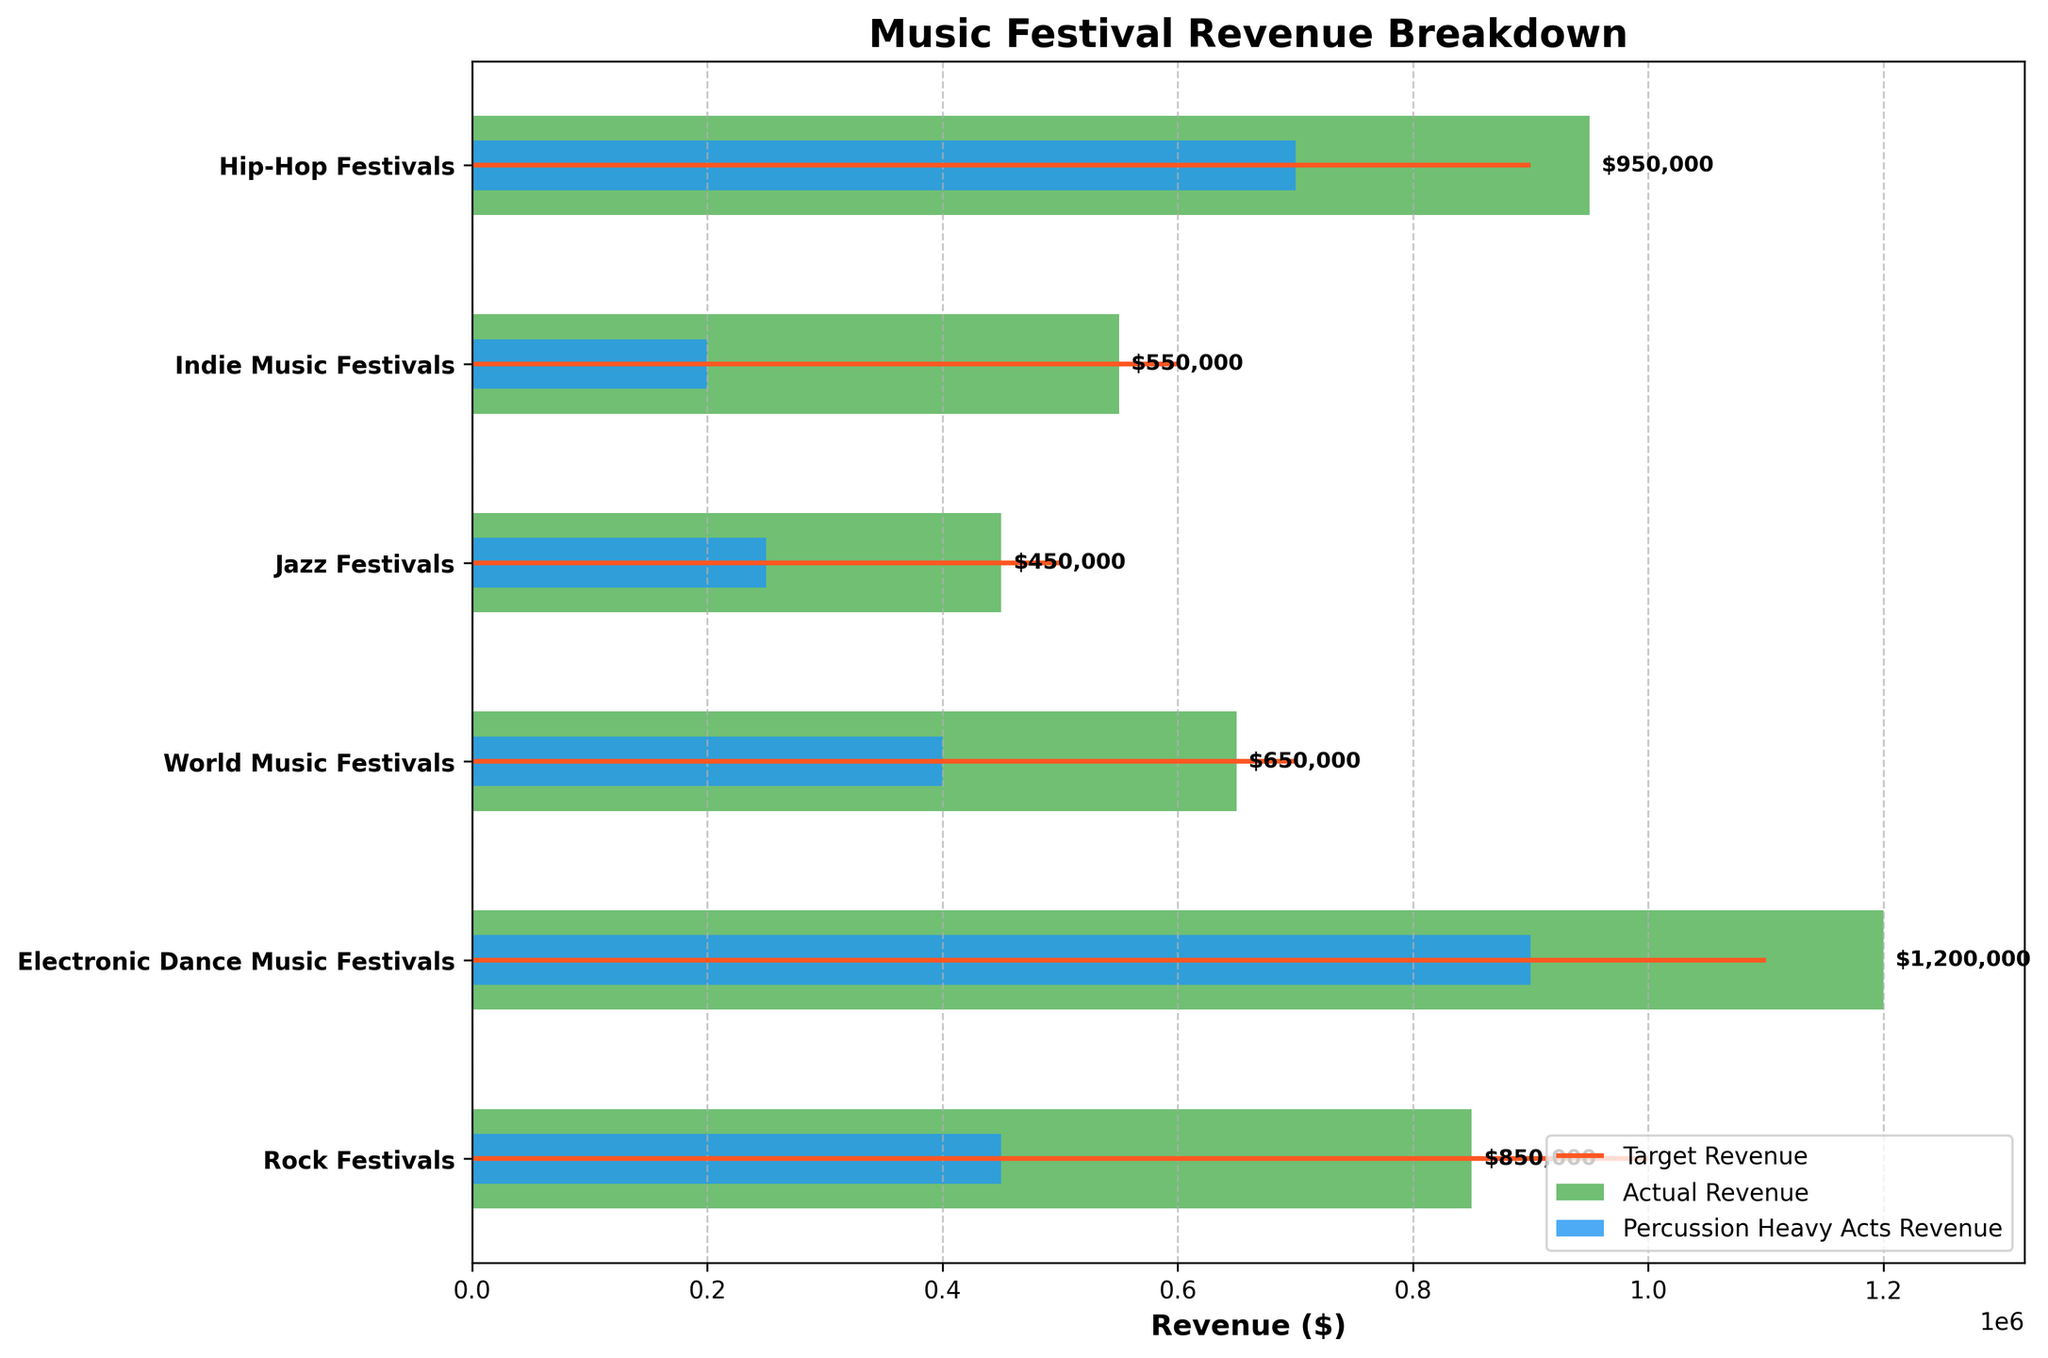What's the title of the chart? The title of the chart is usually found at the top and provides an overview of what the chart represents. In this chart, the title clearly indicates the content.
Answer: Music Festival Revenue Breakdown Which festival has the highest actual revenue? To determine the highest actual revenue, look for the longest green bar in the chart.
Answer: Electronic Dance Music Festivals What is the revenue from percussion-heavy acts for Indie Music Festivals? The blue bar represents the revenue from percussion-heavy acts, and for Indie Music Festivals, this bar is the shortest blue bar in the chart.
Answer: $200,000 How does the actual revenue for Jazz Festivals compare to its target revenue? By observing the length of the green bar (actual revenue) and the red line (target revenue) for Jazz Festivals, you can see if the actual revenue is less than or more than the target.
Answer: Less than the target What is the total actual revenue generated by all festivals? Sum the actual revenue values for all the festivals: 850,000 (Rock) + 1,200,000 (EDM) + 650,000 (World) + 450,000 (Jazz) + 550,000 (Indie) + 950,000 (Hip-Hop) = 4,650,000
Answer: $4,650,000 By how much did the actual revenue for Rock Festivals fall short of its target revenue? Subtract the actual revenue (green bar) from the target revenue (red line) for Rock Festivals: 1,000,000 - 850,000 = 150,000
Answer: $150,000 Which festival has the highest revenue from percussion-heavy acts? Look for the longest blue bar across all categories.
Answer: Electronic Dance Music Festivals How does the actual revenue for World Music Festivals compare to its percussion-heavy acts revenue? Compare the length of the green bar (actual revenue) and the blue bar (percussion-heavy acts revenue) for World Music Festivals. The green bar is longer, indicating higher actual revenue.
Answer: Higher What is the combined revenue from percussion-heavy acts for all festivals? Sum the percussion-heavy acts' revenue values for all festivals: 450,000 (Rock) + 900,000 (EDM) + 400,000 (World) + 250,000 (Jazz) + 200,000 (Indie) + 700,000 (Hip-Hop) = 2,900,000
Answer: $2,900,000 Which festivals met or exceeded their target revenue? Compare the actual revenue (green bars) with the target revenue (red lines) to identify the festivals where the green bar is equal to or longer than the red line.
Answer: Electronic Dance Music Festivals and Hip-Hop Festivals 